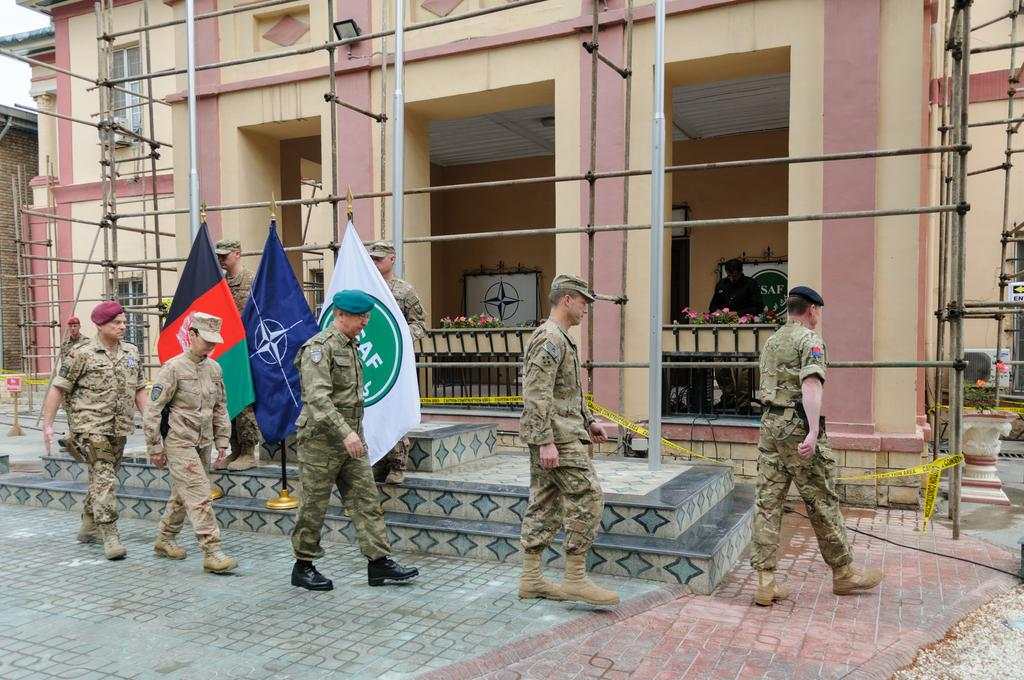What are the people in the image doing? The people in the image are walking on the pavement. What can be seen in the background of the image? There is a building in the background of the image. Are there any additional elements present in the image? Yes, there are flags present in the image. What type of curtain can be seen hanging from the building in the image? There is no curtain visible in the image; only the building and flags are present. How many minutes does it take for the people to walk across the pavement in the image? The image does not provide information about the duration of the people's walk, so it cannot be determined. 